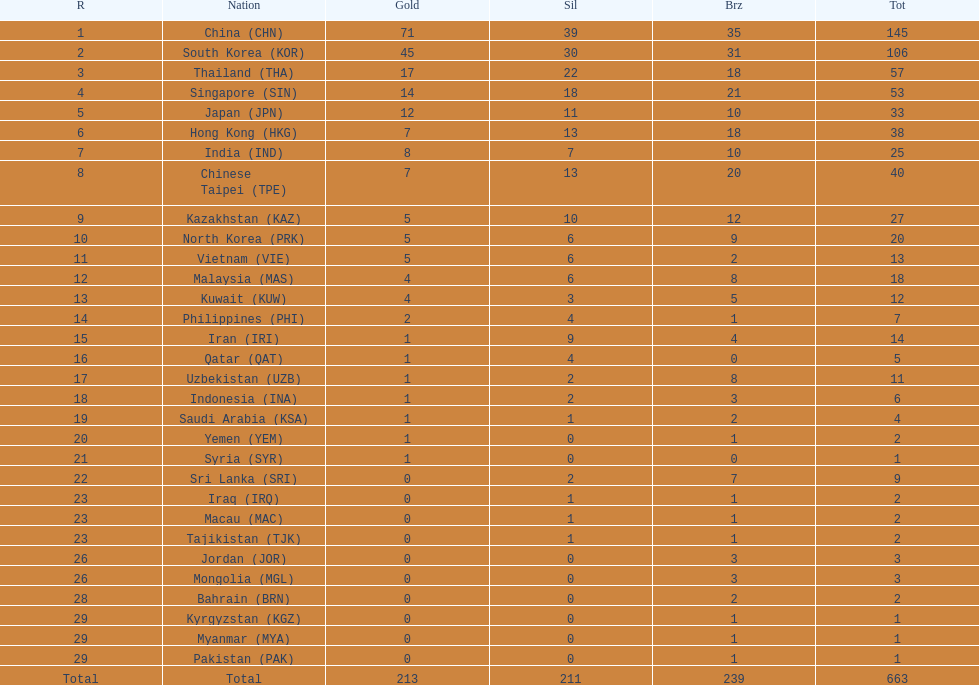What is the difference between the total amount of medals won by qatar and indonesia? 1. 